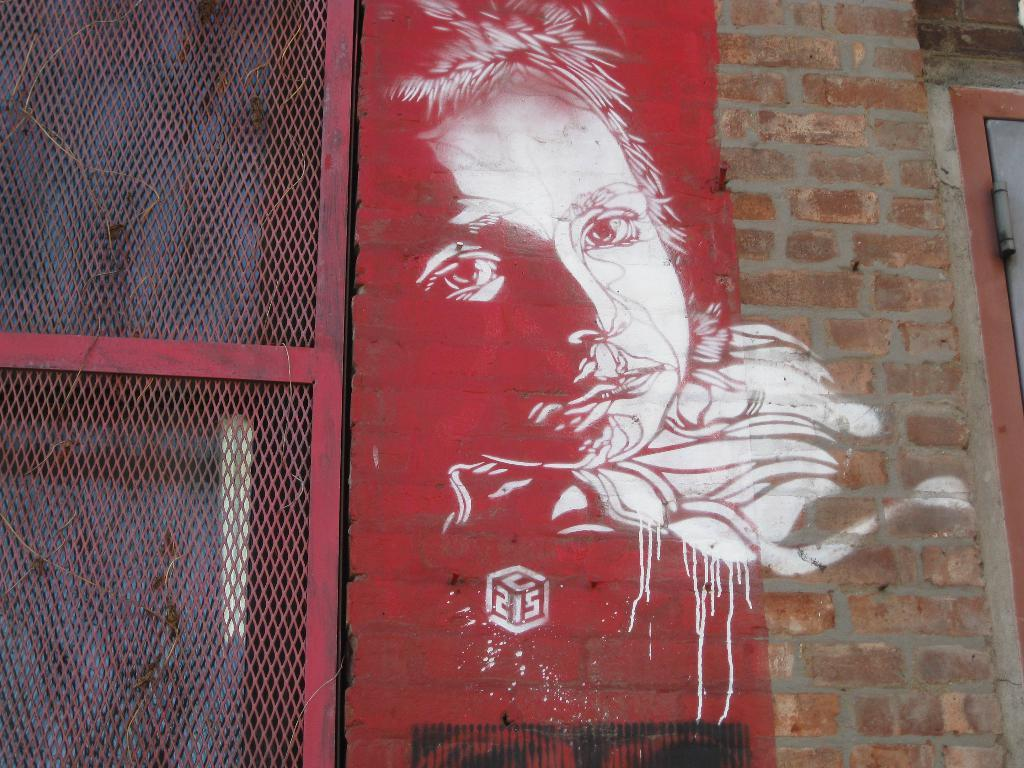What type of structure is present in the image? There is a wall in the image. What features are present on the wall? The wall has a door and a fence. Is there any artwork on the wall? Yes, there is a picture of a person painted on the wall. What type of bird can be seen in the yard in the image? There is no yard or bird present in the image; it only features a wall with a door, a fence, and a painted picture of a person. 